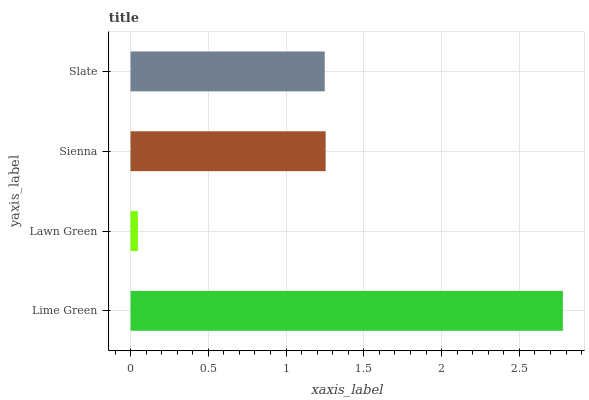Is Lawn Green the minimum?
Answer yes or no. Yes. Is Lime Green the maximum?
Answer yes or no. Yes. Is Sienna the minimum?
Answer yes or no. No. Is Sienna the maximum?
Answer yes or no. No. Is Sienna greater than Lawn Green?
Answer yes or no. Yes. Is Lawn Green less than Sienna?
Answer yes or no. Yes. Is Lawn Green greater than Sienna?
Answer yes or no. No. Is Sienna less than Lawn Green?
Answer yes or no. No. Is Sienna the high median?
Answer yes or no. Yes. Is Slate the low median?
Answer yes or no. Yes. Is Lawn Green the high median?
Answer yes or no. No. Is Lawn Green the low median?
Answer yes or no. No. 